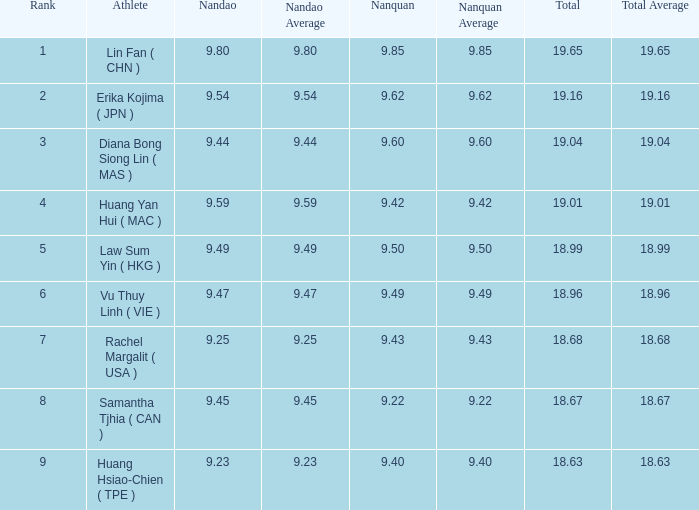Which Nanquan has a Nandao smaller than 9.44, and a Rank smaller than 9, and a Total larger than 18.68? None. Parse the table in full. {'header': ['Rank', 'Athlete', 'Nandao', 'Nandao Average', 'Nanquan', 'Nanquan Average', 'Total', 'Total Average'], 'rows': [['1', 'Lin Fan ( CHN )', '9.80', '9.80', '9.85', '9.85', '19.65', '19.65'], ['2', 'Erika Kojima ( JPN )', '9.54', '9.54', '9.62', '9.62', '19.16', '19.16'], ['3', 'Diana Bong Siong Lin ( MAS )', '9.44', '9.44', '9.60', '9.60', '19.04', '19.04'], ['4', 'Huang Yan Hui ( MAC )', '9.59', '9.59', '9.42', '9.42', '19.01', '19.01'], ['5', 'Law Sum Yin ( HKG )', '9.49', '9.49', '9.50', '9.50', '18.99', '18.99'], ['6', 'Vu Thuy Linh ( VIE )', '9.47', '9.47', '9.49', '9.49', '18.96', '18.96'], ['7', 'Rachel Margalit ( USA )', '9.25', '9.25', '9.43', '9.43', '18.68', '18.68'], ['8', 'Samantha Tjhia ( CAN )', '9.45', '9.45', '9.22', '9.22', '18.67', '18.67'], ['9', 'Huang Hsiao-Chien ( TPE )', '9.23', '9.23', '9.40', '9.40', '18.63', '18.63']]} 